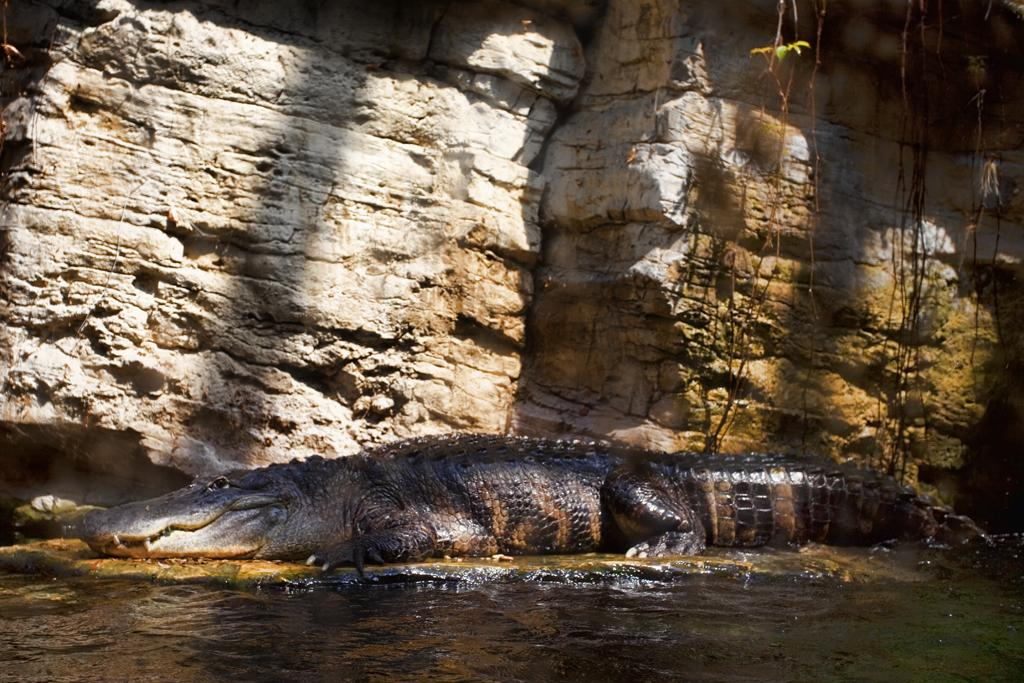What animal is present on the ground in the image? There is a crocodile on the ground in the image. What can be seen in the foreground of the image? There is water visible in the foreground of the image. What type of natural feature is present in the background of the image? There is a rock in the background of the image. What type of bait is being used to catch fish in the image? There is no fishing or bait present in the image; it features a crocodile on the ground with water in the foreground and a rock in the background. 